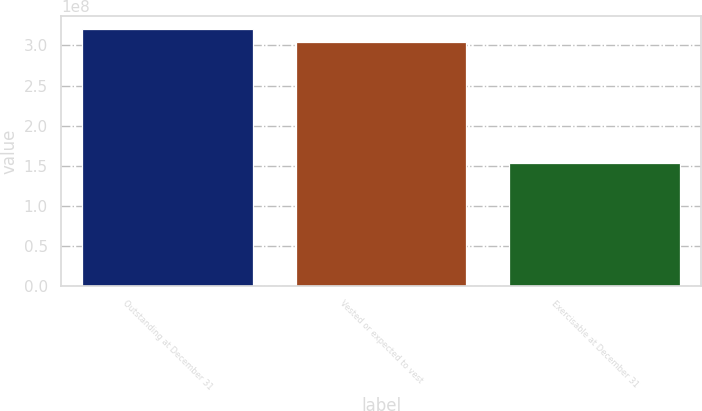Convert chart to OTSL. <chart><loc_0><loc_0><loc_500><loc_500><bar_chart><fcel>Outstanding at December 31<fcel>Vested or expected to vest<fcel>Exercisable at December 31<nl><fcel>3.20363e+08<fcel>3.04394e+08<fcel>1.52742e+08<nl></chart> 